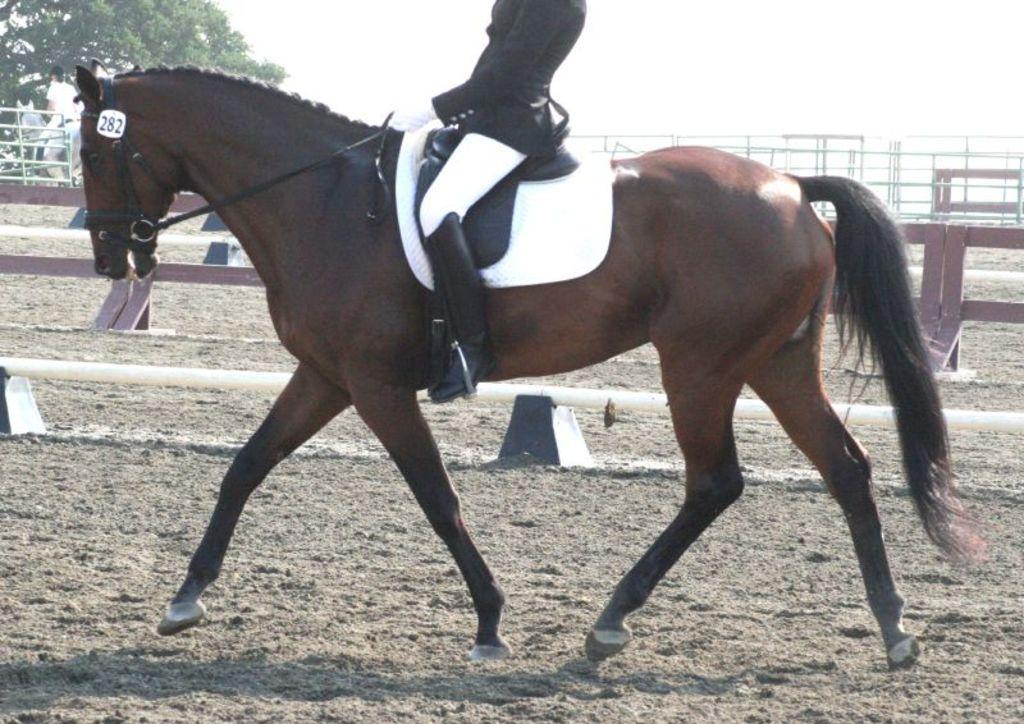Can you describe this image briefly? In the middle of this image, there is a horse, on which there is a person holding thread of it, walking on a ground. In the background, there is a bridge, on which there are few persons, there are trees and there are clouds in the sky. 